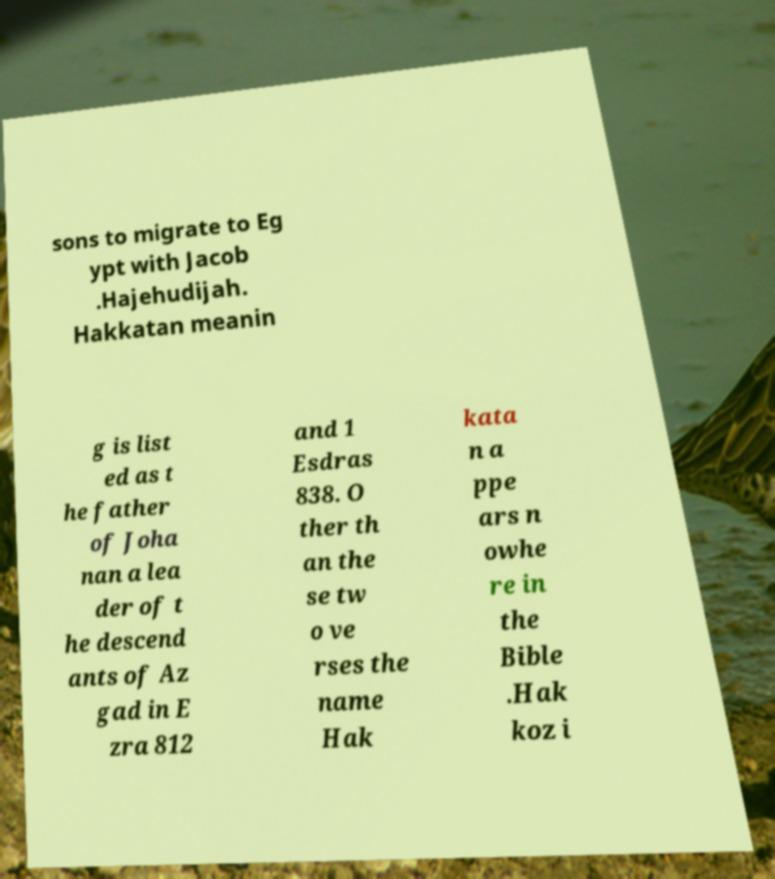Could you extract and type out the text from this image? sons to migrate to Eg ypt with Jacob .Hajehudijah. Hakkatan meanin g is list ed as t he father of Joha nan a lea der of t he descend ants of Az gad in E zra 812 and 1 Esdras 838. O ther th an the se tw o ve rses the name Hak kata n a ppe ars n owhe re in the Bible .Hak koz i 